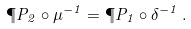<formula> <loc_0><loc_0><loc_500><loc_500>\P P _ { 2 } \circ \mu ^ { - 1 } = \P P _ { 1 } \circ \delta ^ { - 1 } \, .</formula> 